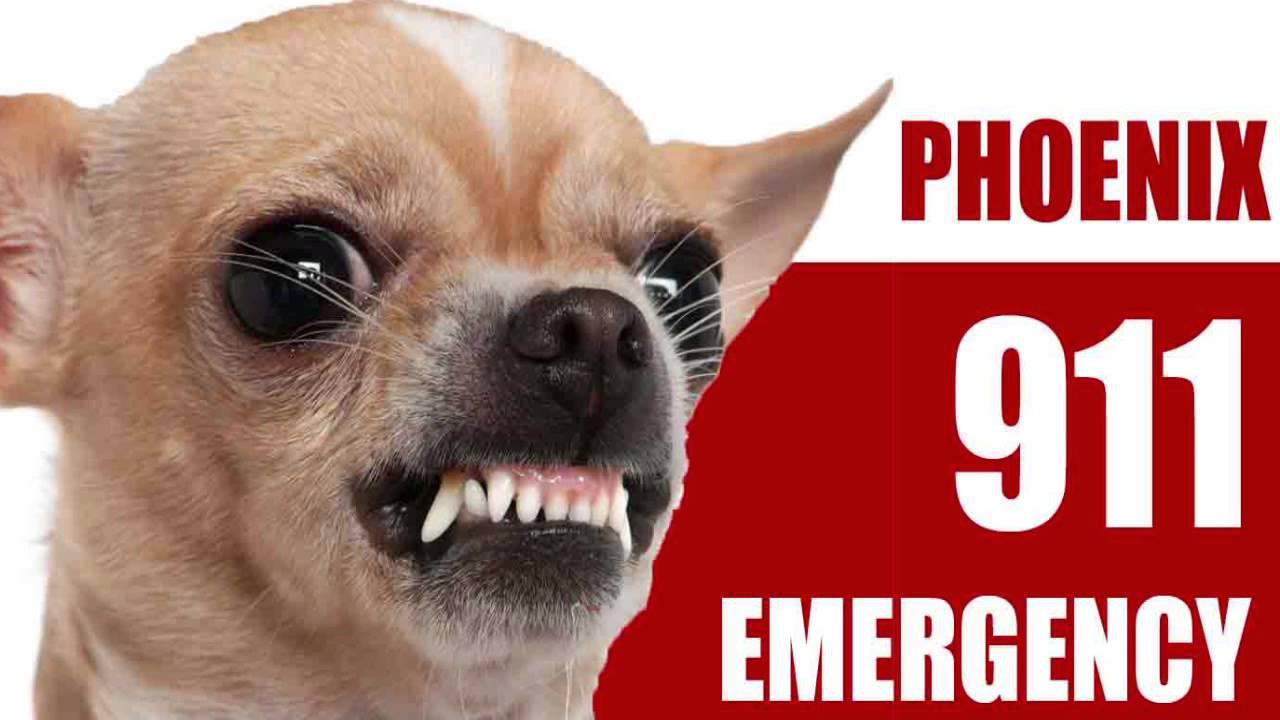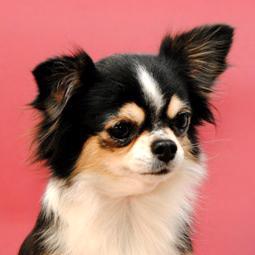The first image is the image on the left, the second image is the image on the right. Given the left and right images, does the statement "An image contains a chihuahua snarling and showing its teeth." hold true? Answer yes or no. Yes. 